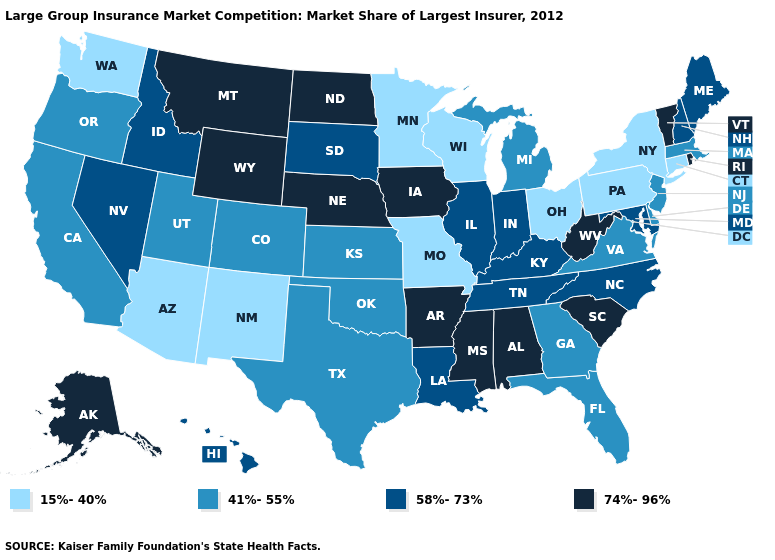What is the highest value in the USA?
Keep it brief. 74%-96%. What is the value of Indiana?
Answer briefly. 58%-73%. Does New York have the same value as Washington?
Write a very short answer. Yes. Among the states that border Kansas , which have the lowest value?
Concise answer only. Missouri. What is the highest value in the USA?
Concise answer only. 74%-96%. What is the highest value in states that border Tennessee?
Concise answer only. 74%-96%. What is the highest value in the USA?
Answer briefly. 74%-96%. Does the first symbol in the legend represent the smallest category?
Short answer required. Yes. Name the states that have a value in the range 58%-73%?
Be succinct. Hawaii, Idaho, Illinois, Indiana, Kentucky, Louisiana, Maine, Maryland, Nevada, New Hampshire, North Carolina, South Dakota, Tennessee. Name the states that have a value in the range 58%-73%?
Short answer required. Hawaii, Idaho, Illinois, Indiana, Kentucky, Louisiana, Maine, Maryland, Nevada, New Hampshire, North Carolina, South Dakota, Tennessee. Does the first symbol in the legend represent the smallest category?
Concise answer only. Yes. Among the states that border Massachusetts , which have the lowest value?
Give a very brief answer. Connecticut, New York. What is the lowest value in states that border New Hampshire?
Give a very brief answer. 41%-55%. Name the states that have a value in the range 41%-55%?
Be succinct. California, Colorado, Delaware, Florida, Georgia, Kansas, Massachusetts, Michigan, New Jersey, Oklahoma, Oregon, Texas, Utah, Virginia. 